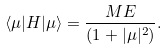Convert formula to latex. <formula><loc_0><loc_0><loc_500><loc_500>\langle \mu | H | \mu \rangle = \frac { M E } { ( 1 + | \mu | ^ { 2 } ) } .</formula> 